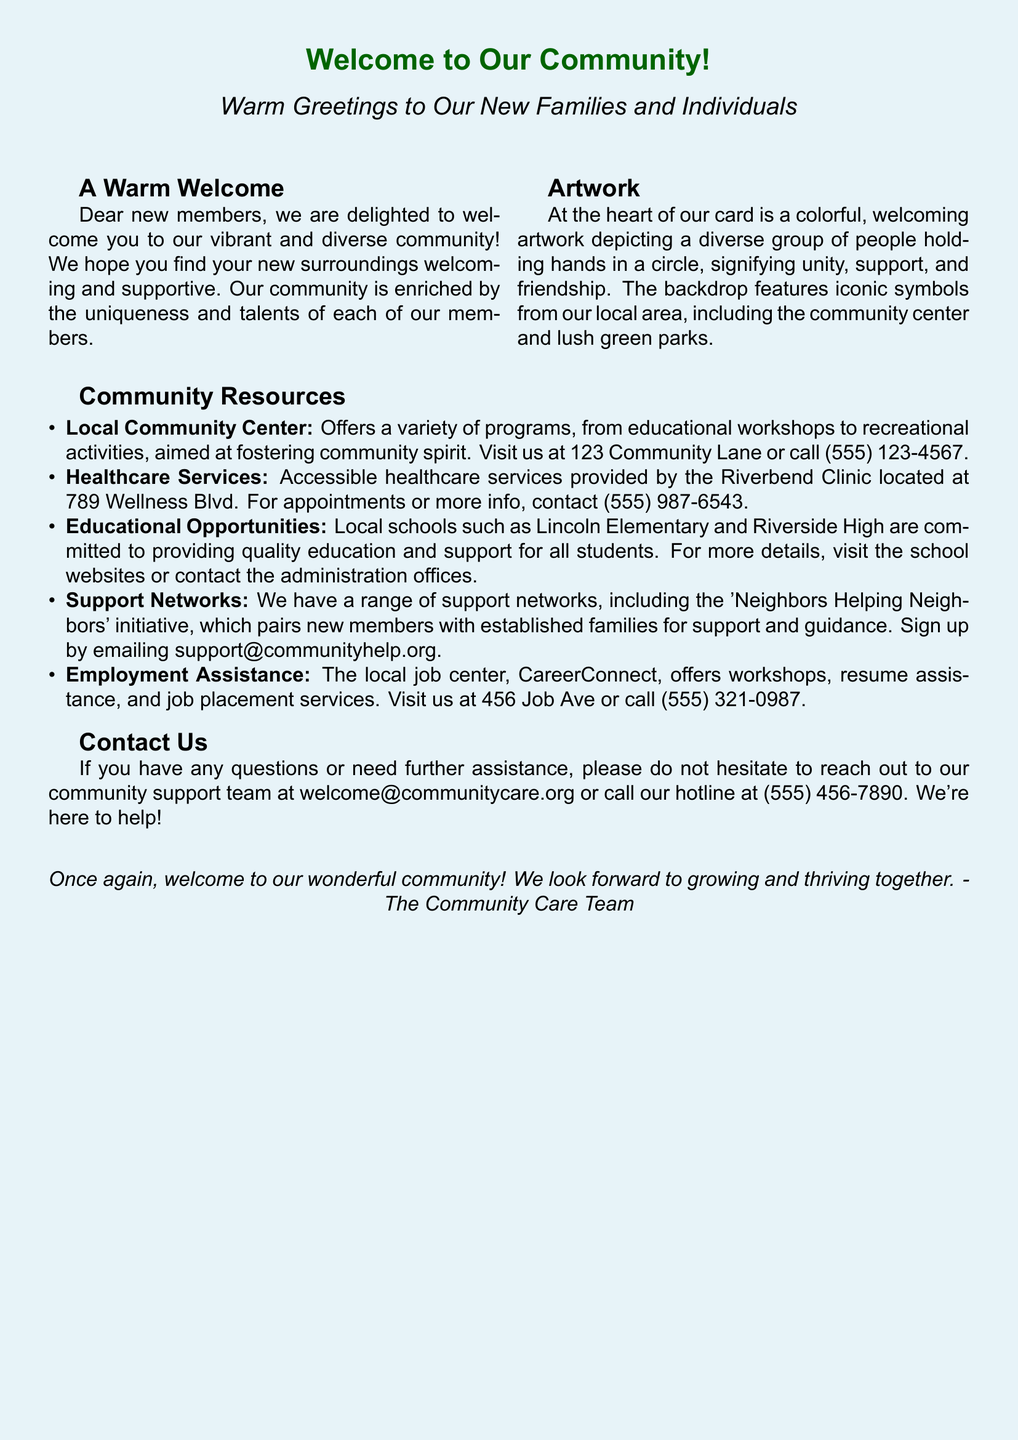What is the title of the card? The title is prominently displayed at the top of the card, welcoming new members.
Answer: Welcome to Our Community! What is the location of the local community center? The document contains contact information for the community center, including its address.
Answer: 123 Community Lane What initiative pairs new members with established families? The document highlights support networks that facilitate assistance for newcomers.
Answer: Neighbors Helping Neighbors What services does Riverbend Clinic provide? The document specifies the nature of healthcare support offered in the community.
Answer: Healthcare services How can new members reach the community support team? The document includes contact information for further assistance.
Answer: welcome@communitycare.org What is depicted in the artwork on the card? The description provides insight into the theme of unity and support in the visual representation.
Answer: A diverse group of people holding hands in a circle What is the phone number for CareerConnect? The document lists contact details for employment assistance programs available locally.
Answer: (555) 321-0987 How does the community plan to grow together? The closing statement indicates the community's vision for inclusivity and mutual support among members.
Answer: Growing and thriving together 